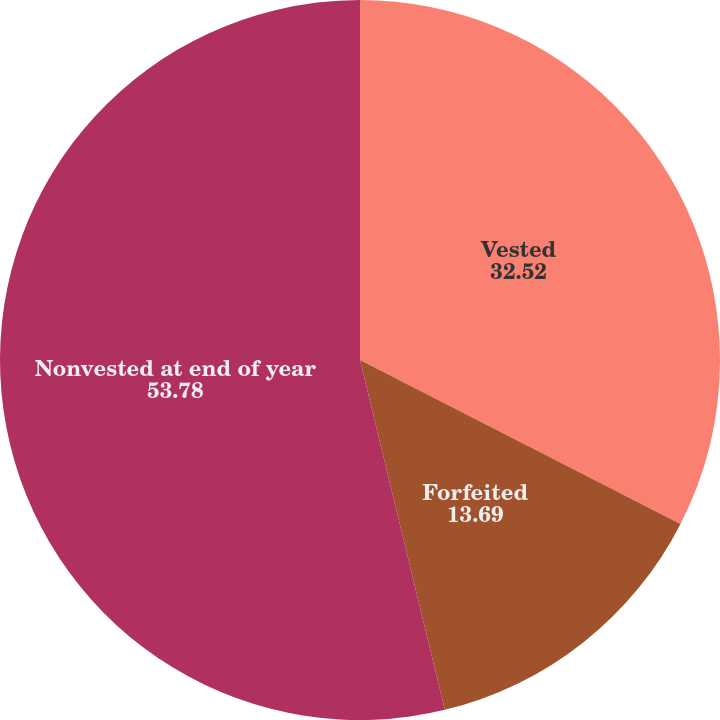Convert chart to OTSL. <chart><loc_0><loc_0><loc_500><loc_500><pie_chart><fcel>Vested<fcel>Forfeited<fcel>Nonvested at end of year<nl><fcel>32.52%<fcel>13.69%<fcel>53.78%<nl></chart> 